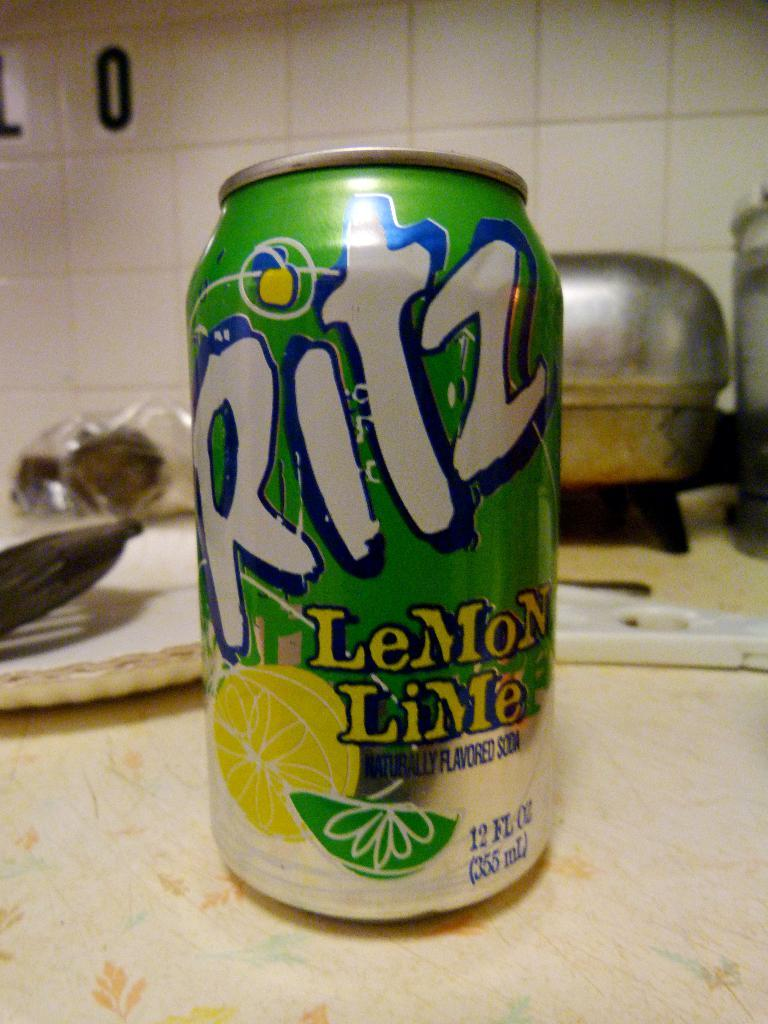<image>
Render a clear and concise summary of the photo. A green can of Ritz soda on a counter says it is naturally flavored soda. 